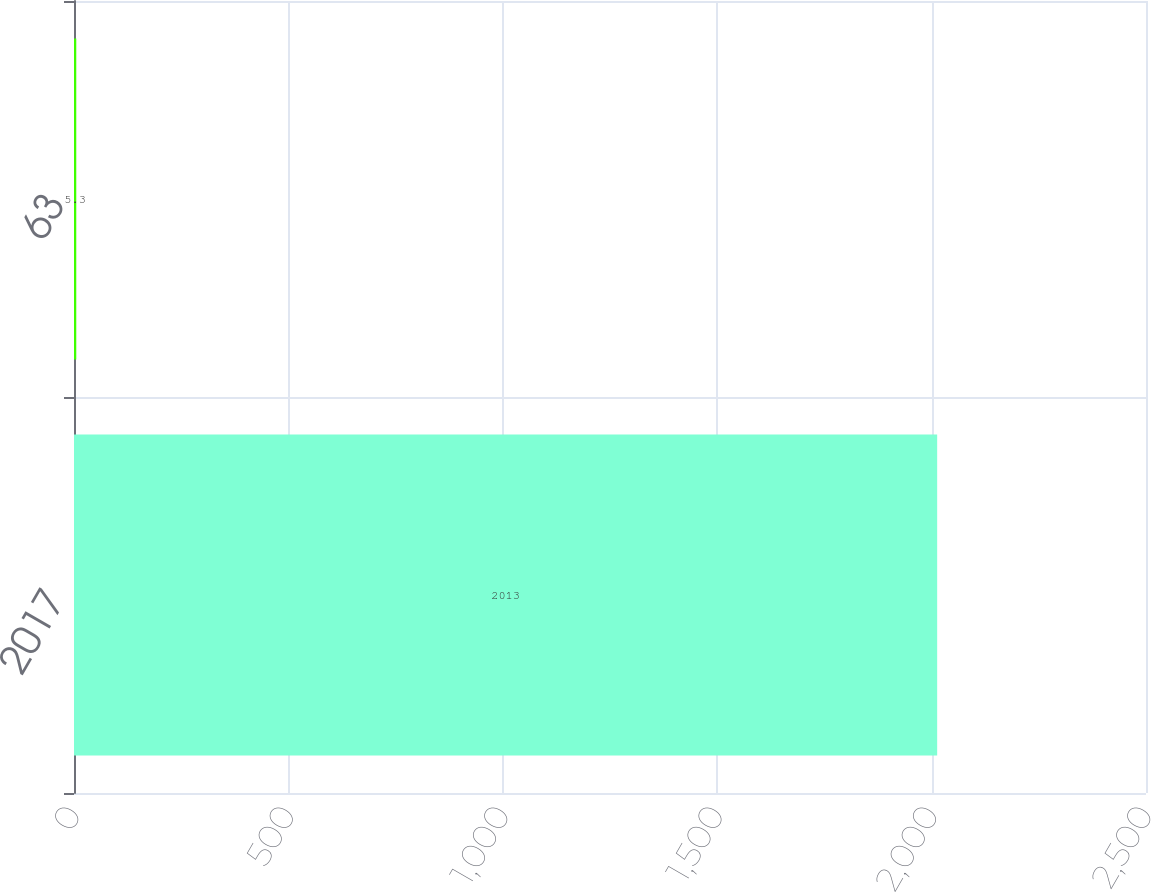Convert chart. <chart><loc_0><loc_0><loc_500><loc_500><bar_chart><fcel>2017<fcel>63<nl><fcel>2013<fcel>5.3<nl></chart> 